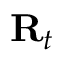<formula> <loc_0><loc_0><loc_500><loc_500>R _ { t }</formula> 